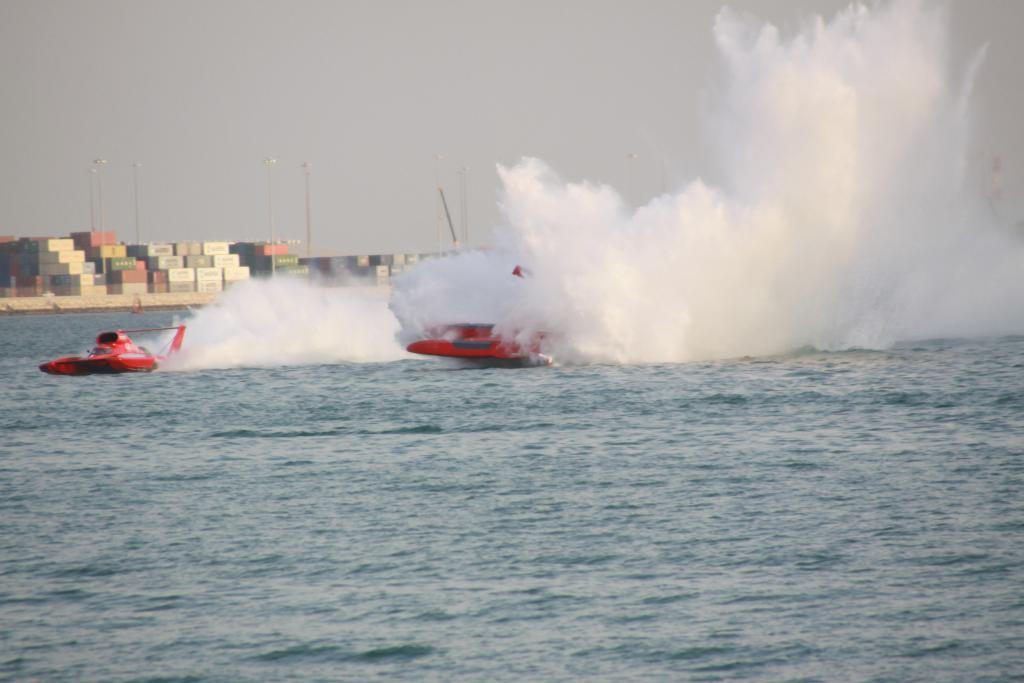What type of vehicles are in the image? There are speed boats in the image. What structures can be seen in the image? There are poles visible in the image. What natural element is present in the image? There is water visible in the image. What is visible in the background of the image? The sky is visible in the background of the image. What type of leather can be seen on the jellyfish in the image? There are no jellyfish present in the image, and therefore no leather can be observed. 